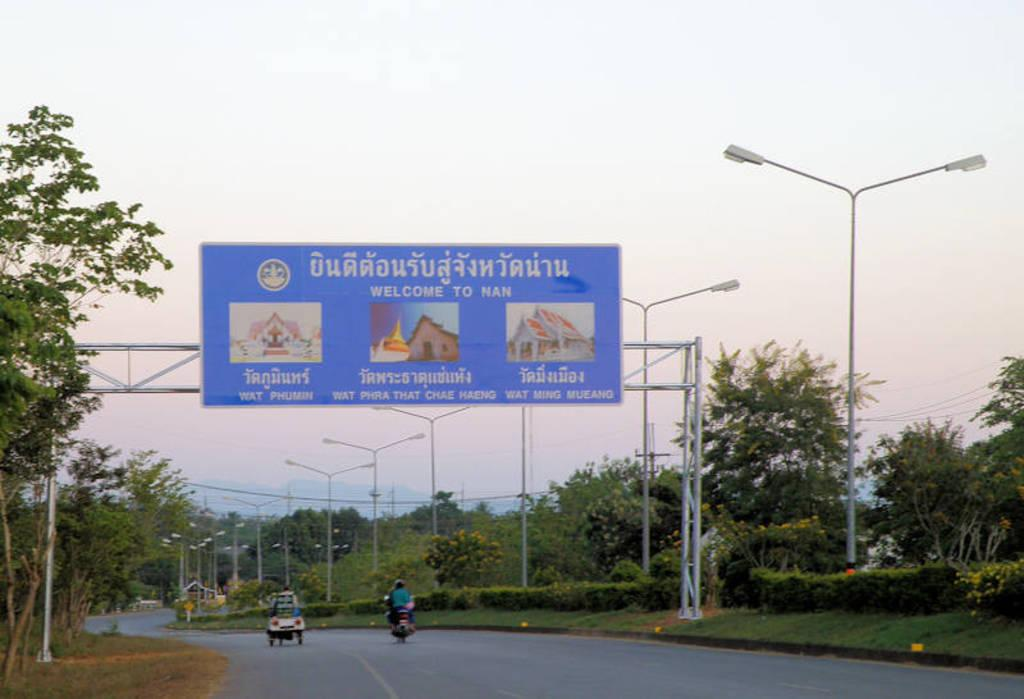<image>
Create a compact narrative representing the image presented. Blue highway sign says "welcome to Nan" above the highway. 